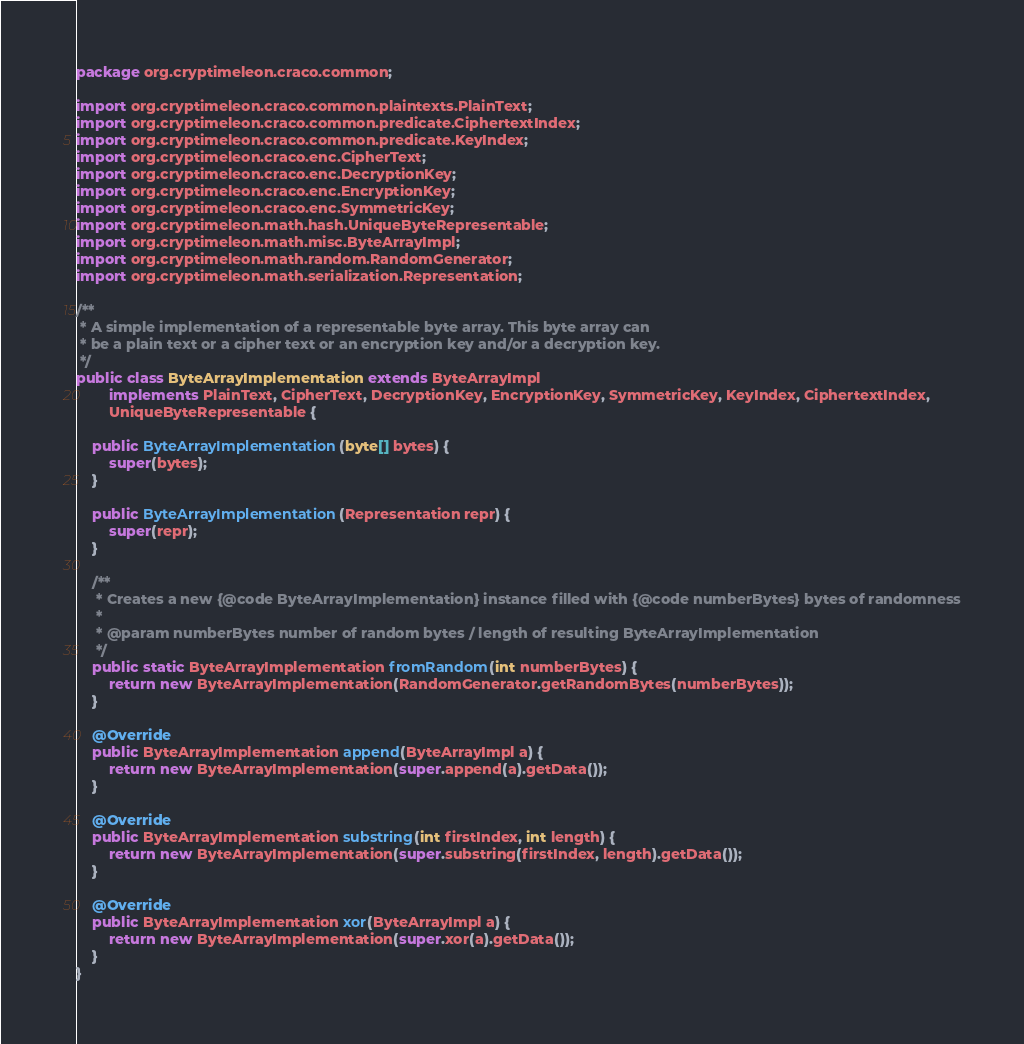<code> <loc_0><loc_0><loc_500><loc_500><_Java_>package org.cryptimeleon.craco.common;

import org.cryptimeleon.craco.common.plaintexts.PlainText;
import org.cryptimeleon.craco.common.predicate.CiphertextIndex;
import org.cryptimeleon.craco.common.predicate.KeyIndex;
import org.cryptimeleon.craco.enc.CipherText;
import org.cryptimeleon.craco.enc.DecryptionKey;
import org.cryptimeleon.craco.enc.EncryptionKey;
import org.cryptimeleon.craco.enc.SymmetricKey;
import org.cryptimeleon.math.hash.UniqueByteRepresentable;
import org.cryptimeleon.math.misc.ByteArrayImpl;
import org.cryptimeleon.math.random.RandomGenerator;
import org.cryptimeleon.math.serialization.Representation;

/**
 * A simple implementation of a representable byte array. This byte array can
 * be a plain text or a cipher text or an encryption key and/or a decryption key.
 */
public class ByteArrayImplementation extends ByteArrayImpl
        implements PlainText, CipherText, DecryptionKey, EncryptionKey, SymmetricKey, KeyIndex, CiphertextIndex,
        UniqueByteRepresentable {

    public ByteArrayImplementation(byte[] bytes) {
        super(bytes);
    }

    public ByteArrayImplementation(Representation repr) {
        super(repr);
    }

    /**
     * Creates a new {@code ByteArrayImplementation} instance filled with {@code numberBytes} bytes of randomness
     *
     * @param numberBytes number of random bytes / length of resulting ByteArrayImplementation
     */
    public static ByteArrayImplementation fromRandom(int numberBytes) {
        return new ByteArrayImplementation(RandomGenerator.getRandomBytes(numberBytes));
    }

    @Override
    public ByteArrayImplementation append(ByteArrayImpl a) {
        return new ByteArrayImplementation(super.append(a).getData());
    }

    @Override
    public ByteArrayImplementation substring(int firstIndex, int length) {
        return new ByteArrayImplementation(super.substring(firstIndex, length).getData());
    }

    @Override
    public ByteArrayImplementation xor(ByteArrayImpl a) {
        return new ByteArrayImplementation(super.xor(a).getData());
    }
}
</code> 